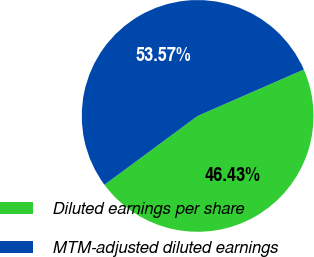Convert chart. <chart><loc_0><loc_0><loc_500><loc_500><pie_chart><fcel>Diluted earnings per share<fcel>MTM-adjusted diluted earnings<nl><fcel>46.43%<fcel>53.57%<nl></chart> 